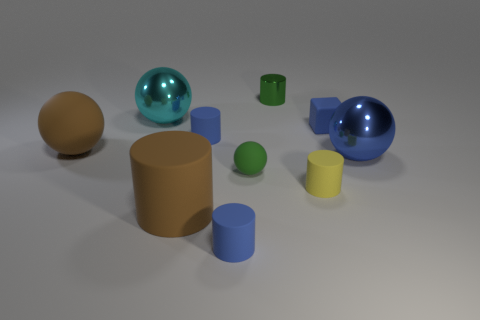There is a sphere that is the same color as the large cylinder; what size is it?
Offer a terse response. Large. Does the small ball have the same color as the small metallic thing?
Give a very brief answer. Yes. Do the big cylinder and the green object in front of the cube have the same material?
Give a very brief answer. Yes. The blue matte thing to the right of the blue thing in front of the big brown rubber cylinder is what shape?
Give a very brief answer. Cube. There is a blue cylinder that is in front of the yellow matte cylinder; is its size the same as the big brown sphere?
Keep it short and to the point. No. How many other objects are there of the same shape as the tiny green rubber object?
Make the answer very short. 3. Do the large matte thing behind the brown rubber cylinder and the large cylinder have the same color?
Your answer should be compact. Yes. Are there any things of the same color as the small sphere?
Give a very brief answer. Yes. There is a cyan ball; what number of large brown balls are left of it?
Provide a succinct answer. 1. What number of other things are the same size as the blue block?
Ensure brevity in your answer.  5. 